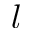<formula> <loc_0><loc_0><loc_500><loc_500>l</formula> 